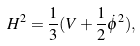Convert formula to latex. <formula><loc_0><loc_0><loc_500><loc_500>H ^ { 2 } = \frac { 1 } { 3 } ( V + \frac { 1 } { 2 } \dot { \phi } ^ { 2 } ) ,</formula> 